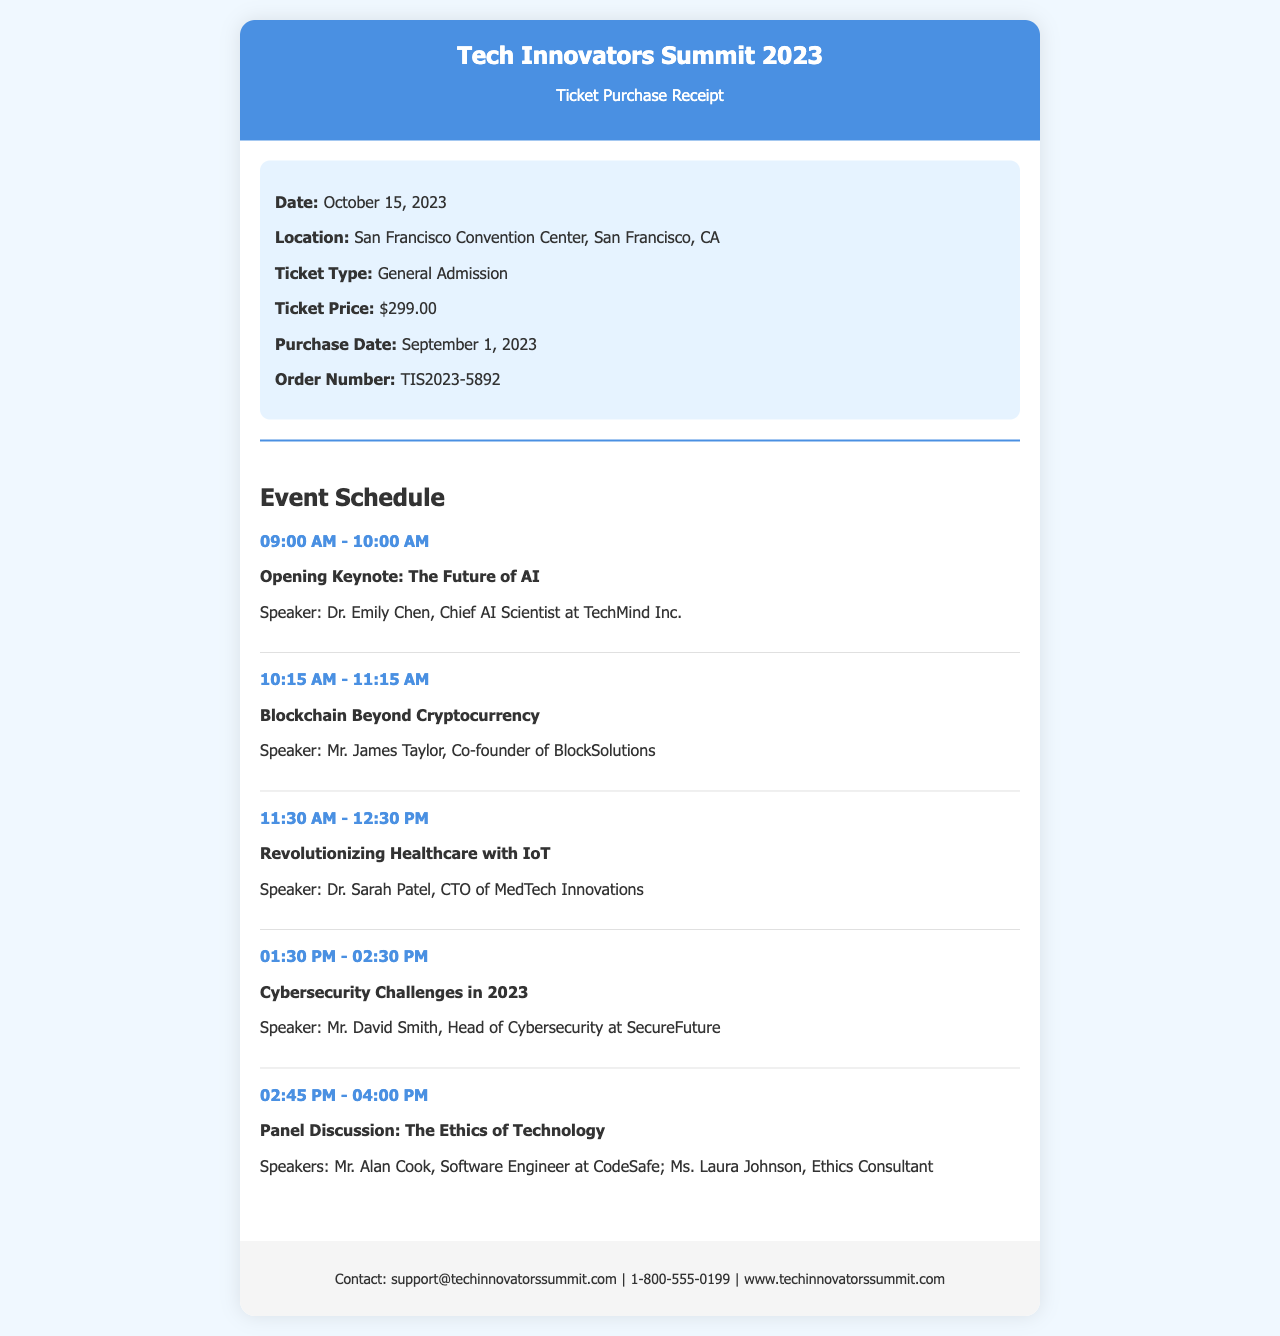what is the date of the conference? The document specifies that the conference takes place on October 15, 2023.
Answer: October 15, 2023 what is the location of the event? The document states that the event is held at the San Francisco Convention Center, San Francisco, CA.
Answer: San Francisco Convention Center, San Francisco, CA who is the speaker for the opening keynote? The opening keynote features Dr. Emily Chen as the speaker, as mentioned in the schedule.
Answer: Dr. Emily Chen what is the ticket price? The ticket price listed in the document is $299.00.
Answer: $299.00 which topic is discussed between 01:30 PM and 02:30 PM? The topic during that time slot is Cybersecurity Challenges in 2023, according to the schedule.
Answer: Cybersecurity Challenges in 2023 how many speakers are there for the panel discussion? The panel discussion has two speakers listed in the document.
Answer: 2 what is the order number for the ticket purchase? The order number provided in the document is TIS2023-5892.
Answer: TIS2023-5892 what is the purchase date of the ticket? The ticket purchase date mentioned in the document is September 1, 2023.
Answer: September 1, 2023 what is the main theme of the first session? The first session's main theme is The Future of AI, as stated in the event schedule.
Answer: The Future of AI 